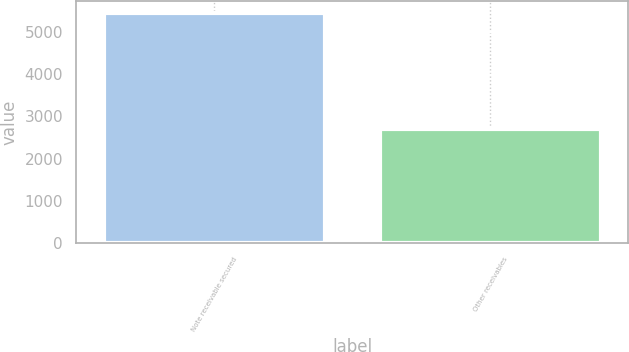Convert chart. <chart><loc_0><loc_0><loc_500><loc_500><bar_chart><fcel>Note receivable secured<fcel>Other receivables<nl><fcel>5448<fcel>2708.3<nl></chart> 